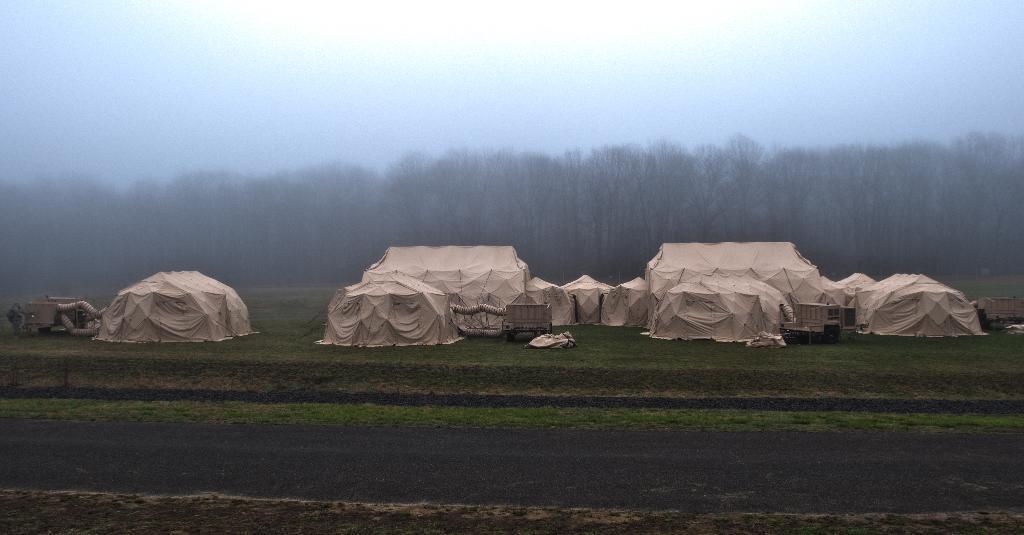Describe this image in one or two sentences. In the center of the image there are tents. In the background there are trees and sky. At the bottom there is a road. 